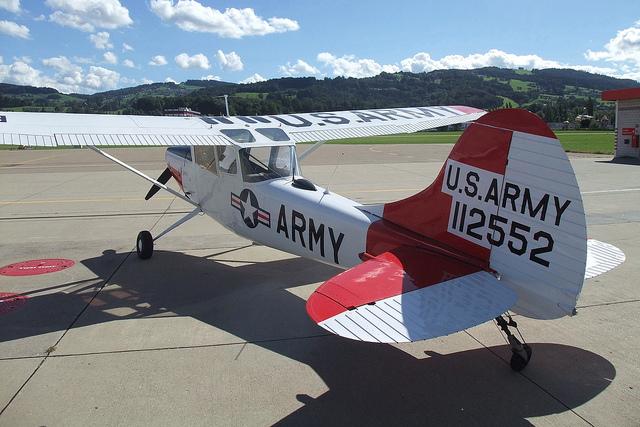Is this a Navy plane?
Short answer required. No. Where is this?
Concise answer only. Airport. Can this plane land on water?
Write a very short answer. No. Are we looking down at the plane?
Answer briefly. Yes. What is written on the plane?
Keep it brief. Us army. 